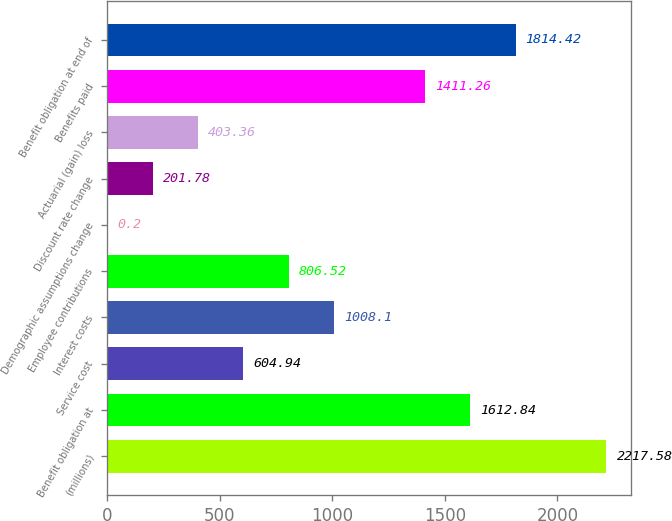Convert chart. <chart><loc_0><loc_0><loc_500><loc_500><bar_chart><fcel>(millions)<fcel>Benefit obligation at<fcel>Service cost<fcel>Interest costs<fcel>Employee contributions<fcel>Demographic assumptions change<fcel>Discount rate change<fcel>Actuarial (gain) loss<fcel>Benefits paid<fcel>Benefit obligation at end of<nl><fcel>2217.58<fcel>1612.84<fcel>604.94<fcel>1008.1<fcel>806.52<fcel>0.2<fcel>201.78<fcel>403.36<fcel>1411.26<fcel>1814.42<nl></chart> 